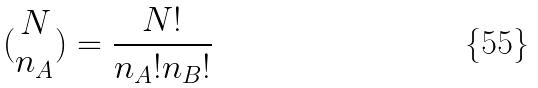<formula> <loc_0><loc_0><loc_500><loc_500>( \begin{matrix} N \\ n _ { A } \end{matrix} ) = \frac { N ! } { n _ { A } ! n _ { B } ! }</formula> 